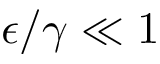Convert formula to latex. <formula><loc_0><loc_0><loc_500><loc_500>\epsilon / \gamma \ll 1</formula> 